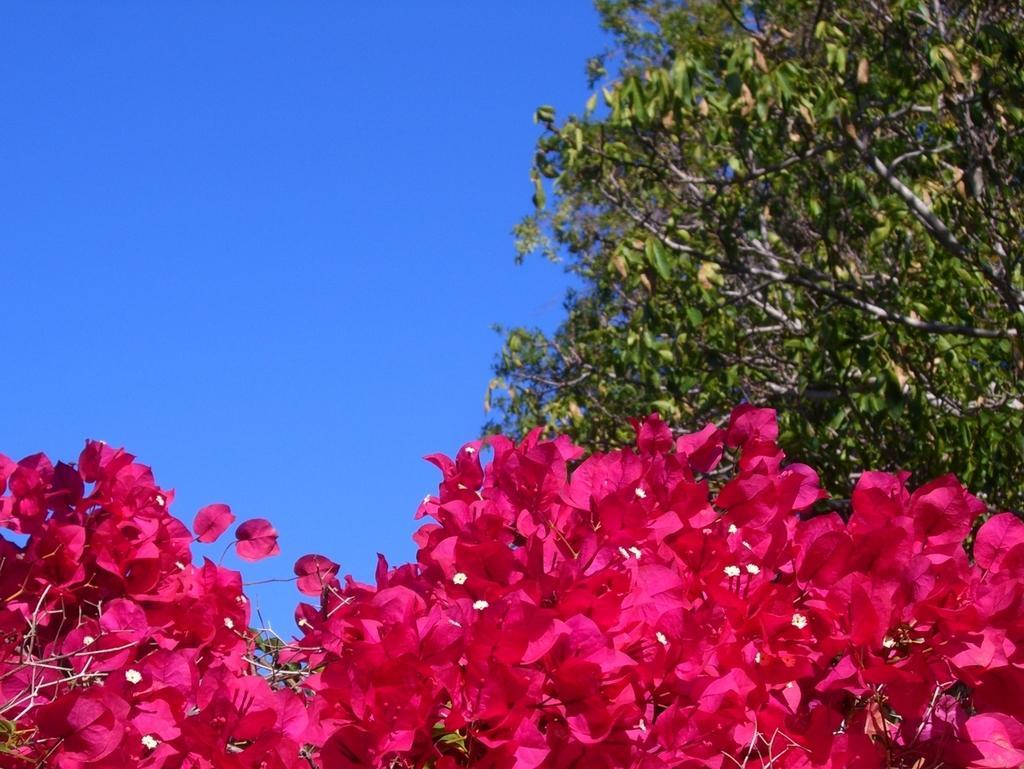Please provide a concise description of this image. In this picture we can see trees, flowers and in the background we can see the sky. 